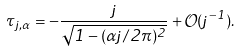Convert formula to latex. <formula><loc_0><loc_0><loc_500><loc_500>\tau _ { j , \alpha } = - \frac { j } { \sqrt { 1 - ( \alpha j / 2 \pi ) ^ { 2 } } } + { \mathcal { O } } ( j ^ { - 1 } ) .</formula> 